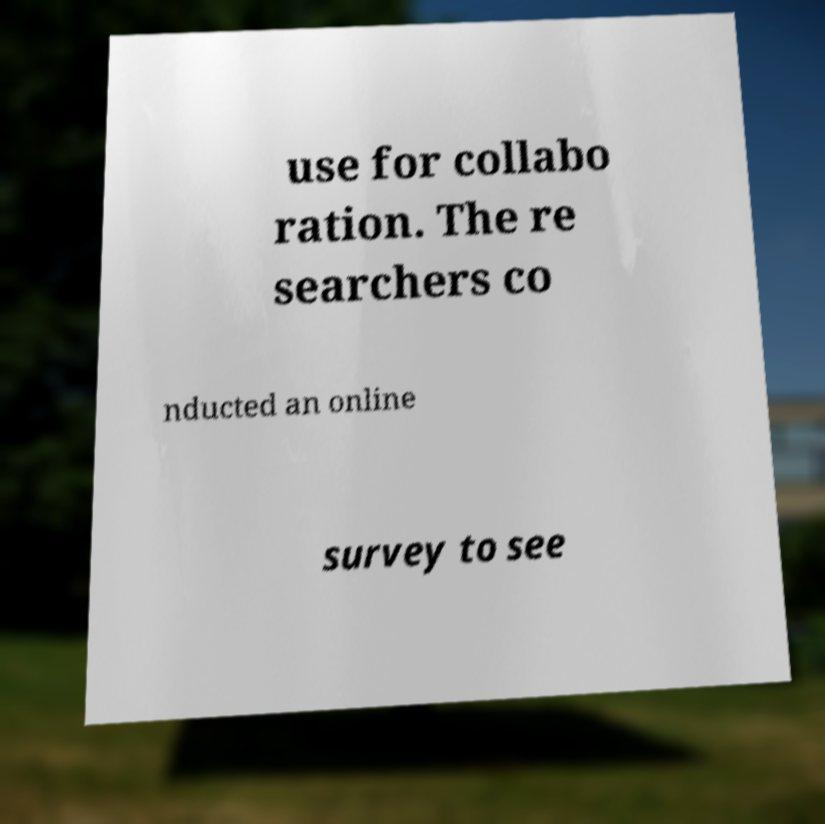What messages or text are displayed in this image? I need them in a readable, typed format. use for collabo ration. The re searchers co nducted an online survey to see 